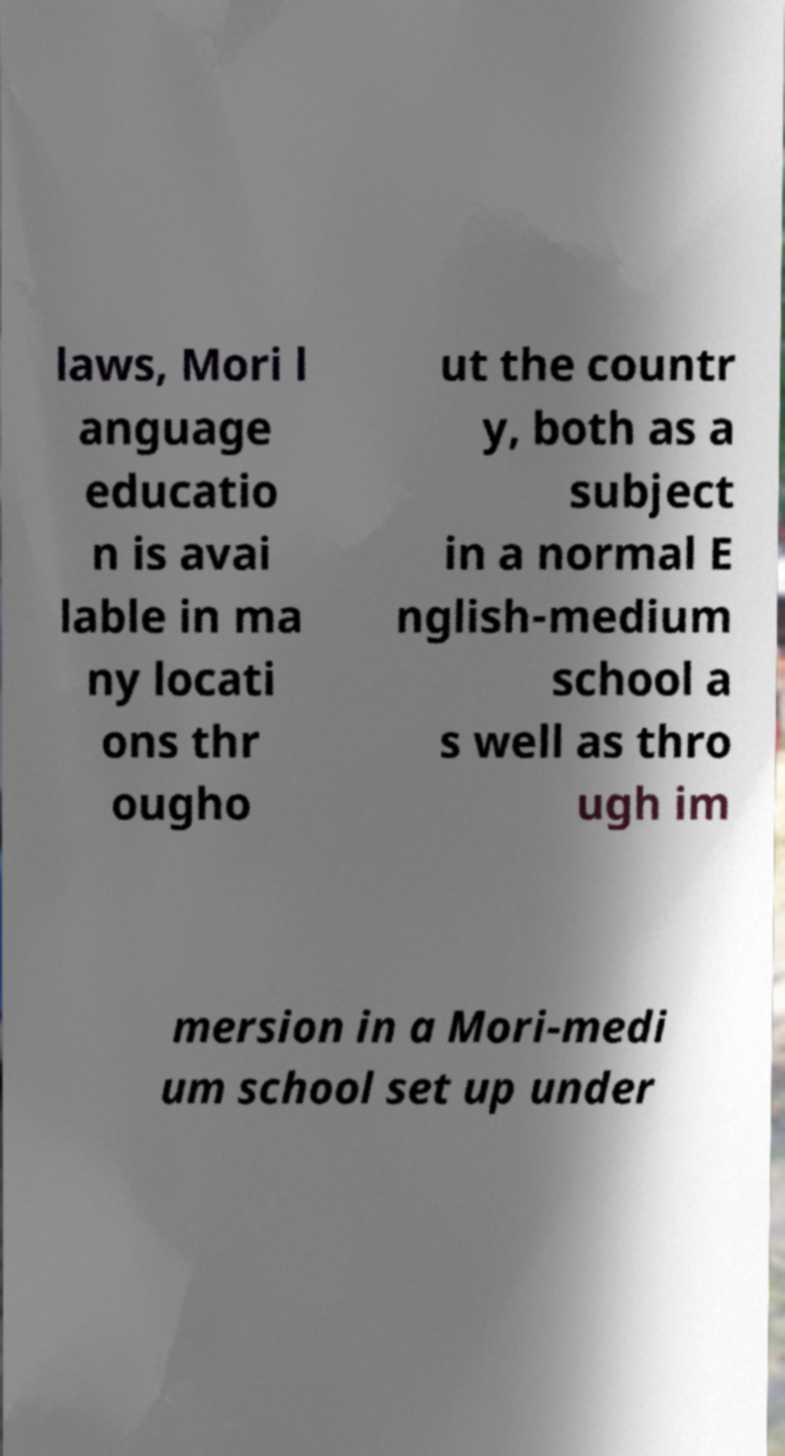I need the written content from this picture converted into text. Can you do that? laws, Mori l anguage educatio n is avai lable in ma ny locati ons thr ougho ut the countr y, both as a subject in a normal E nglish-medium school a s well as thro ugh im mersion in a Mori-medi um school set up under 